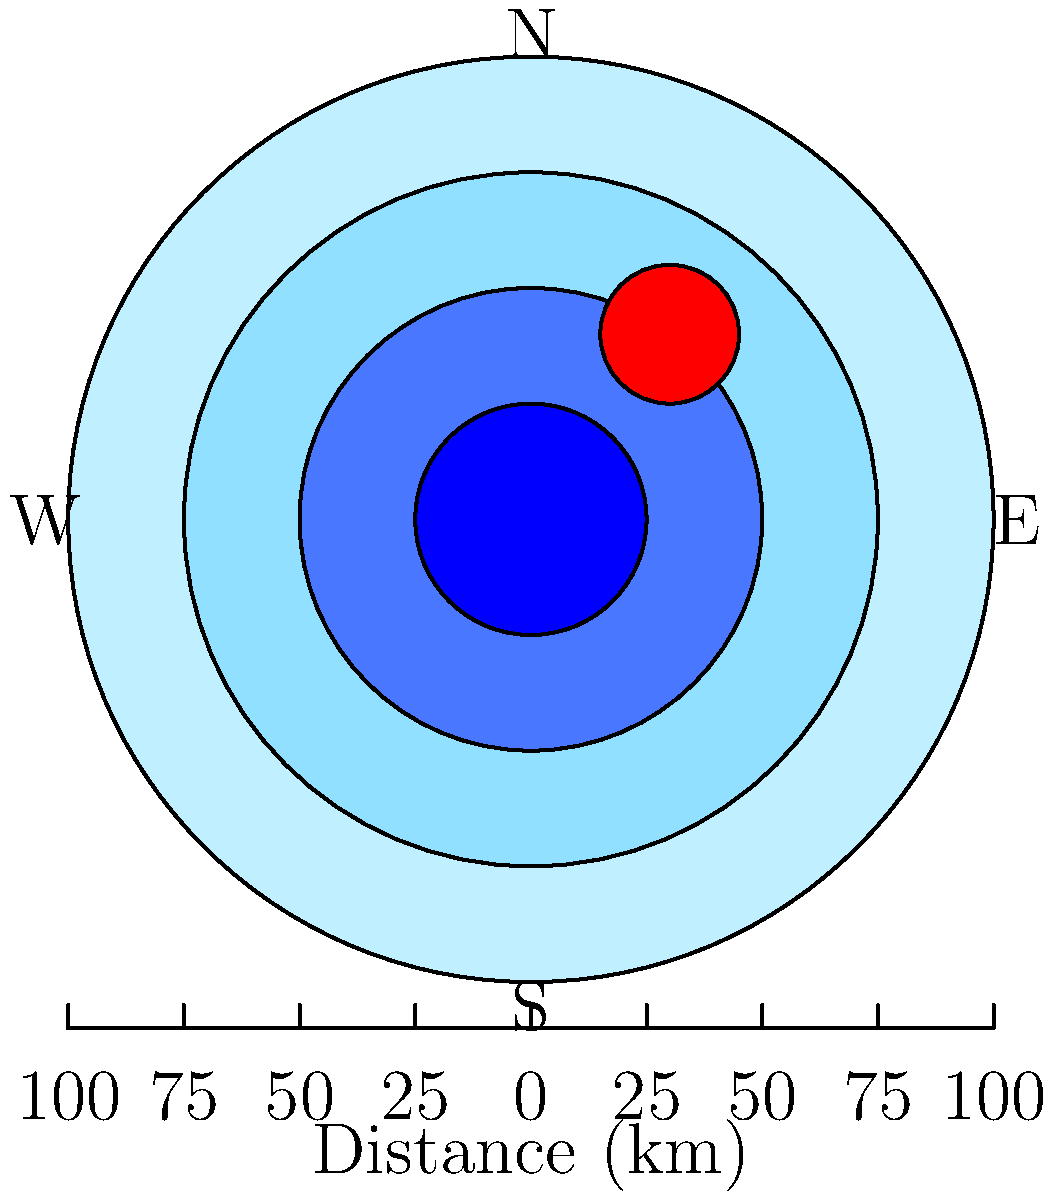Based on the weather radar image above, which shows storm intensity using different colors, what is the approximate diameter of the most intense part of the storm cell, and in which direction is it located relative to the radar center? To answer this question, we need to follow these steps:

1. Identify the storm cell: The red circular area represents the most intense part of the storm cell.

2. Estimate the diameter: 
   - The radar image has concentric circles representing distances from the center.
   - Each circle is 25 km apart (based on the scale at the bottom).
   - The red storm cell appears to be about 30 km in diameter (slightly more than the distance between two circles).

3. Determine the direction:
   - The radar center is at the middle of the image.
   - The storm cell is located up and to the right from the center.
   - This puts it in the northeast quadrant.

4. Refine the direction:
   - It appears to be closer to north than east.
   - We can estimate it's approximately northeast (NE) or north-northeast (NNE).

Therefore, the most intense part of the storm cell has an approximate diameter of 30 km and is located in the north-northeast (NNE) direction from the radar center.
Answer: 30 km diameter, north-northeast (NNE) direction 